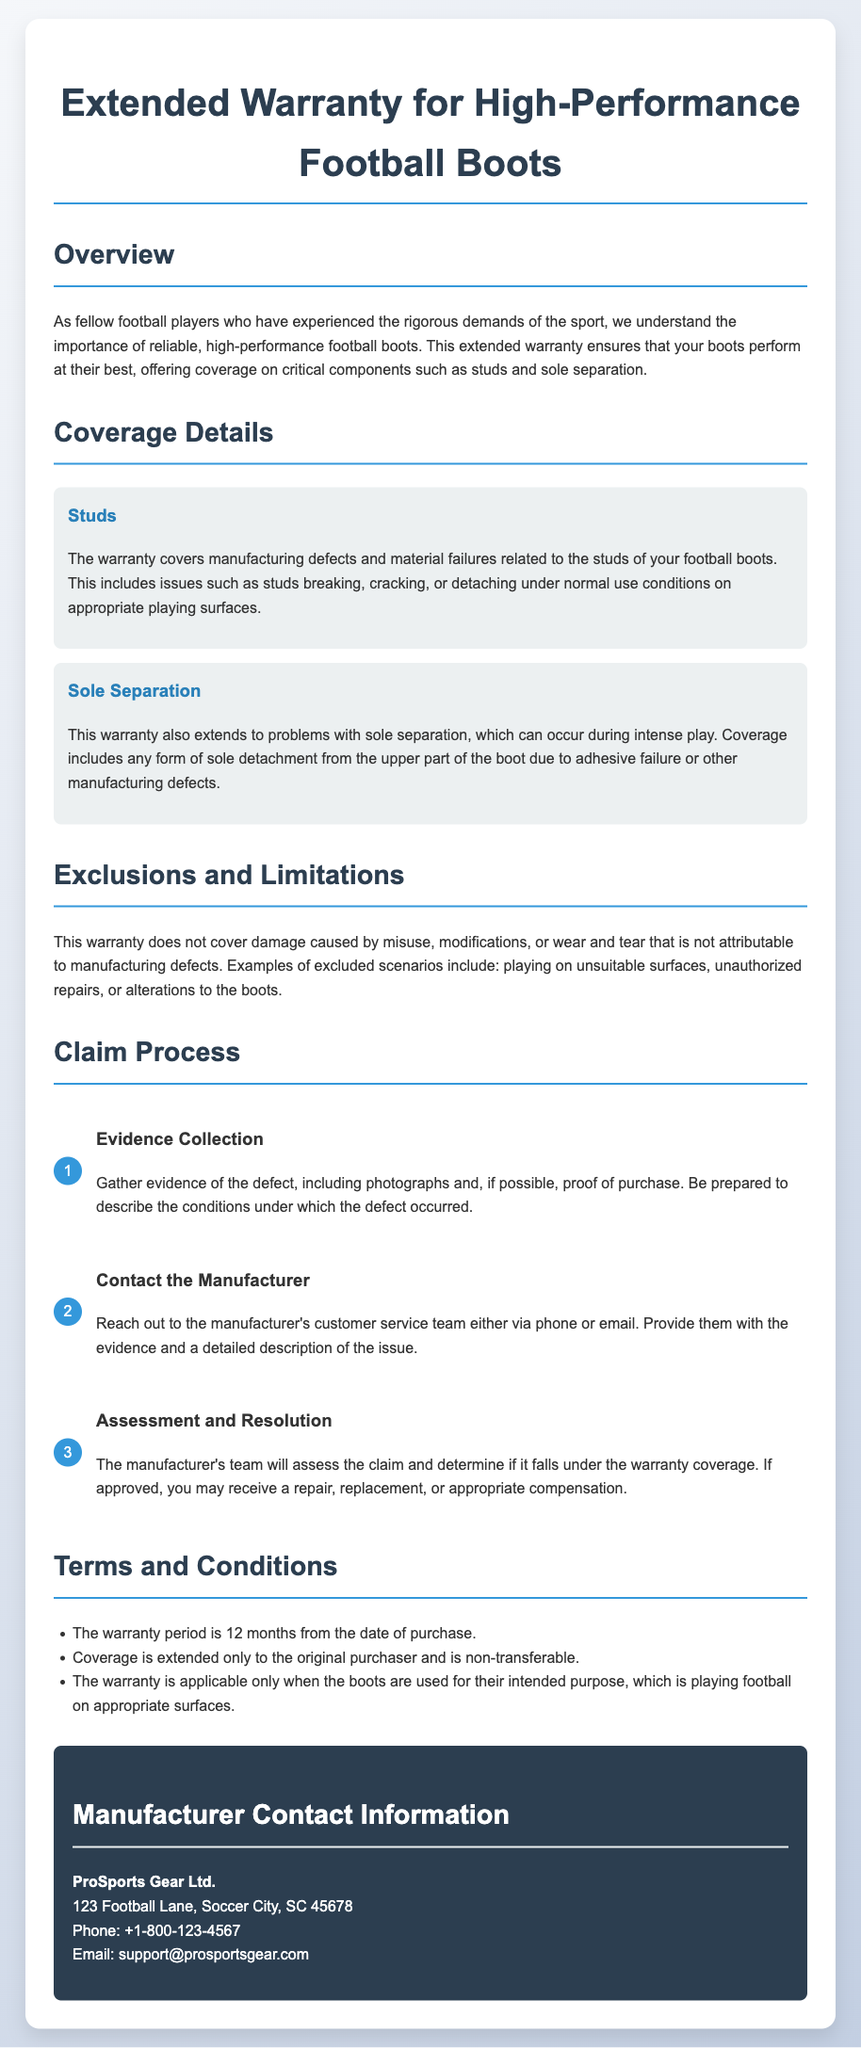what is the warranty period? The document states that the warranty period is 12 months from the date of purchase.
Answer: 12 months who does the warranty coverage extend to? The coverage is extended only to the original purchaser and is non-transferable.
Answer: original purchaser what does the warranty cover regarding studs? The warranty covers manufacturing defects and material failures related to the studs.
Answer: manufacturing defects and material failures which company's contact information is provided? The section mentions ProSports Gear Ltd. as the manufacturer.
Answer: ProSports Gear Ltd what is required for the claim process in the first step? In the first step, evidence of the defect, including photographs and proof of purchase, must be gathered.
Answer: evidence of the defect, including photographs and proof of purchase what damages are excluded from the warranty? The warranty does not cover damage caused by misuse, modifications, or wear and tear not attributable to manufacturing defects.
Answer: misuse, modifications, or wear and tear not attributable to manufacturing defects what is the first action to take when making a claim? The first action is to gather evidence of the defect.
Answer: gather evidence of the defect how can the manufacturer be contacted? The document provides both phone and email as contact methods for the manufacturer.
Answer: phone and email 